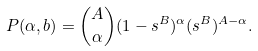Convert formula to latex. <formula><loc_0><loc_0><loc_500><loc_500>P ( \alpha , b ) = { A \choose \alpha } ( 1 - s ^ { B } ) ^ { \alpha } ( s ^ { B } ) ^ { A - \alpha } .</formula> 